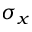<formula> <loc_0><loc_0><loc_500><loc_500>\sigma _ { x }</formula> 